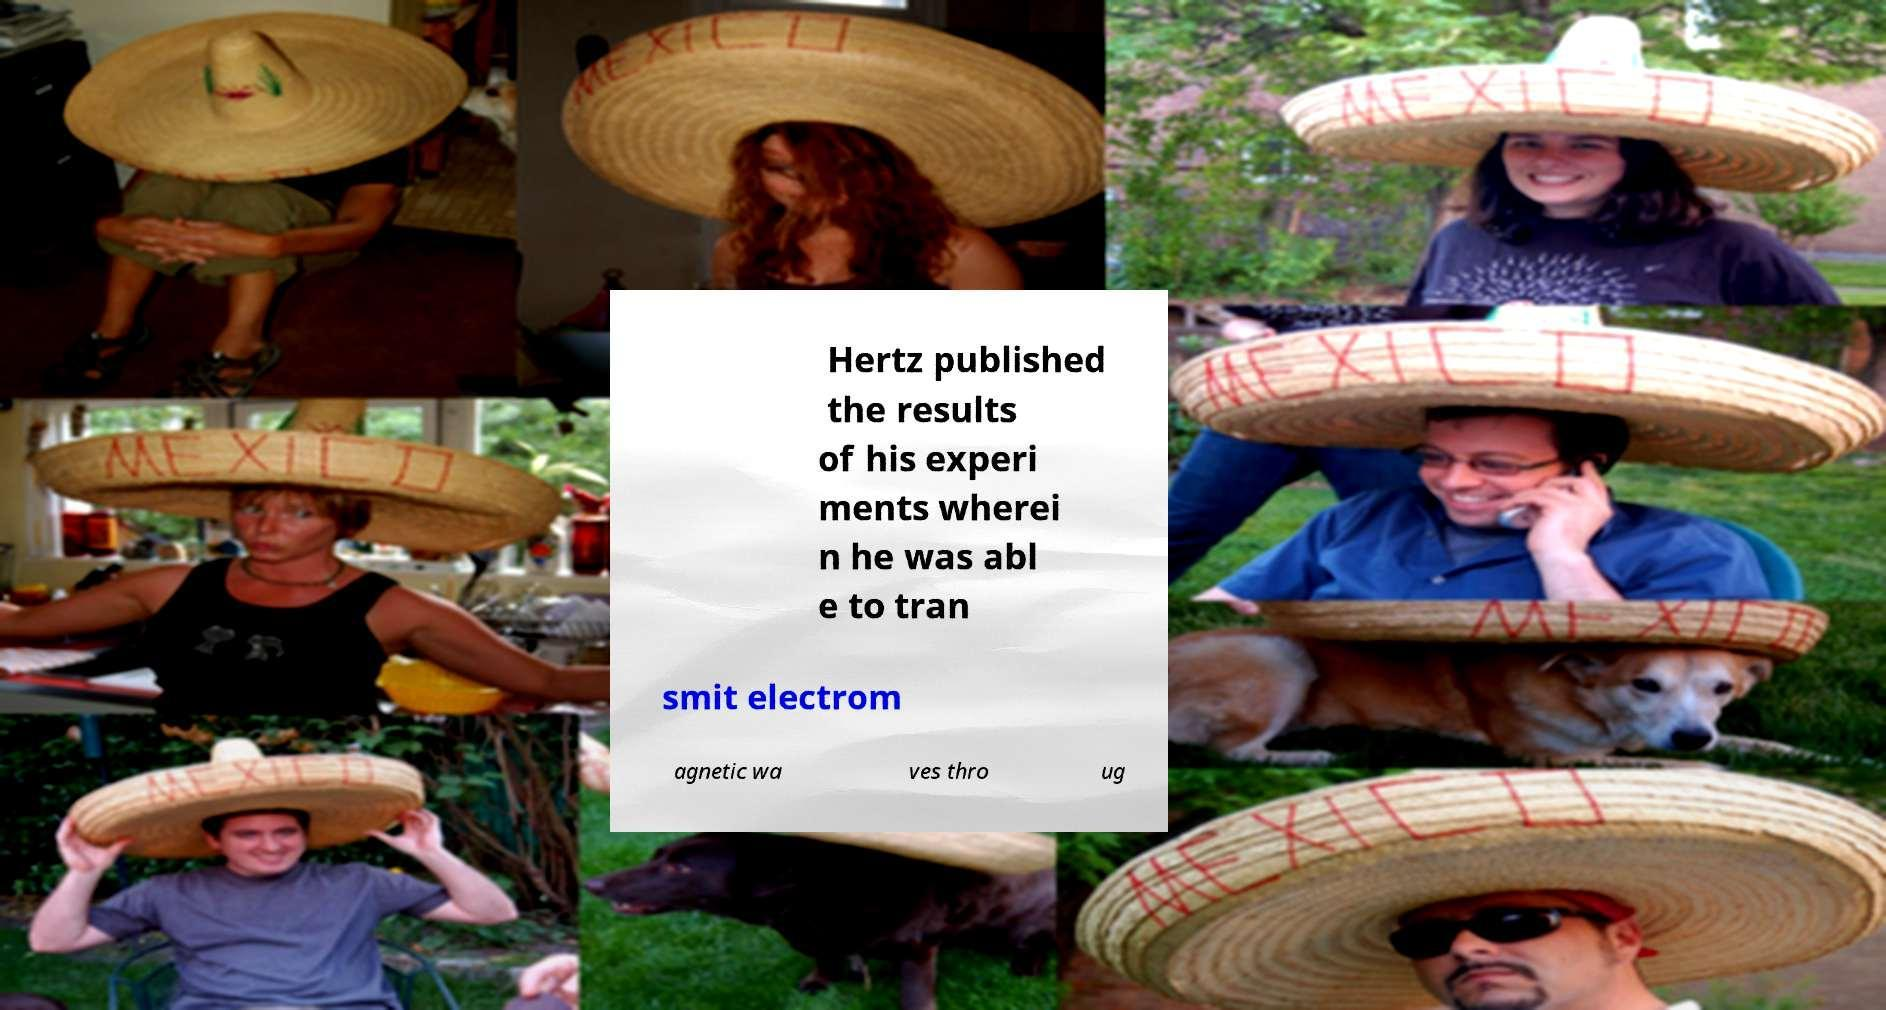Can you read and provide the text displayed in the image?This photo seems to have some interesting text. Can you extract and type it out for me? Hertz published the results of his experi ments wherei n he was abl e to tran smit electrom agnetic wa ves thro ug 